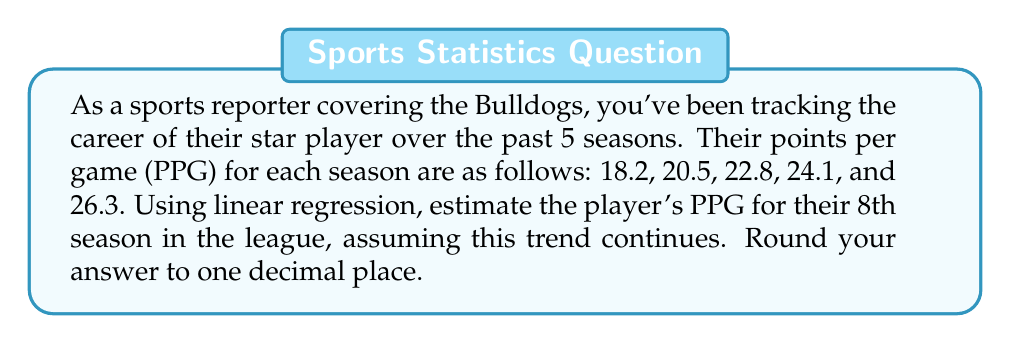Help me with this question. To solve this problem, we'll use linear regression to model the player's career trajectory:

1. Let's define our variables:
   $x$: season number (1, 2, 3, 4, 5)
   $y$: points per game (18.2, 20.5, 22.8, 24.1, 26.3)

2. We need to calculate the following sums:
   $n = 5$ (number of seasons)
   $\sum x = 1 + 2 + 3 + 4 + 5 = 15$
   $\sum y = 18.2 + 20.5 + 22.8 + 24.1 + 26.3 = 111.9$
   $\sum xy = (1)(18.2) + (2)(20.5) + (3)(22.8) + (4)(24.1) + (5)(26.3) = 351.5$
   $\sum x^2 = 1^2 + 2^2 + 3^2 + 4^2 + 5^2 = 55$

3. Use the linear regression formula to find the slope (m) and y-intercept (b):

   $$m = \frac{n\sum xy - \sum x \sum y}{n\sum x^2 - (\sum x)^2}$$
   $$m = \frac{5(351.5) - (15)(111.9)}{5(55) - (15)^2} = \frac{1757.5 - 1678.5}{275 - 225} = \frac{79}{50} = 1.58$$

   $$b = \frac{\sum y - m\sum x}{n}$$
   $$b = \frac{111.9 - 1.58(15)}{5} = \frac{111.9 - 23.7}{5} = 17.64$$

4. The linear regression equation is:
   $$y = 1.58x + 17.64$$

5. To estimate the PPG for the 8th season, we substitute $x = 8$:
   $$y = 1.58(8) + 17.64 = 12.64 + 17.64 = 30.28$$

6. Rounding to one decimal place: 30.3 PPG
Answer: 30.3 PPG 